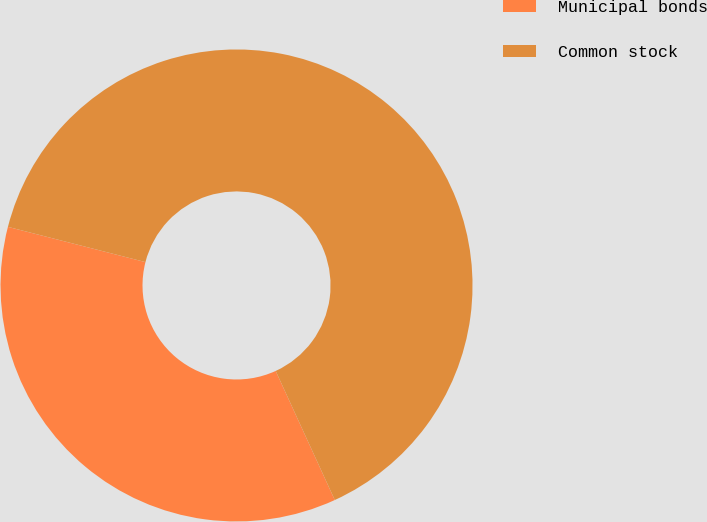Convert chart to OTSL. <chart><loc_0><loc_0><loc_500><loc_500><pie_chart><fcel>Municipal bonds<fcel>Common stock<nl><fcel>35.83%<fcel>64.17%<nl></chart> 